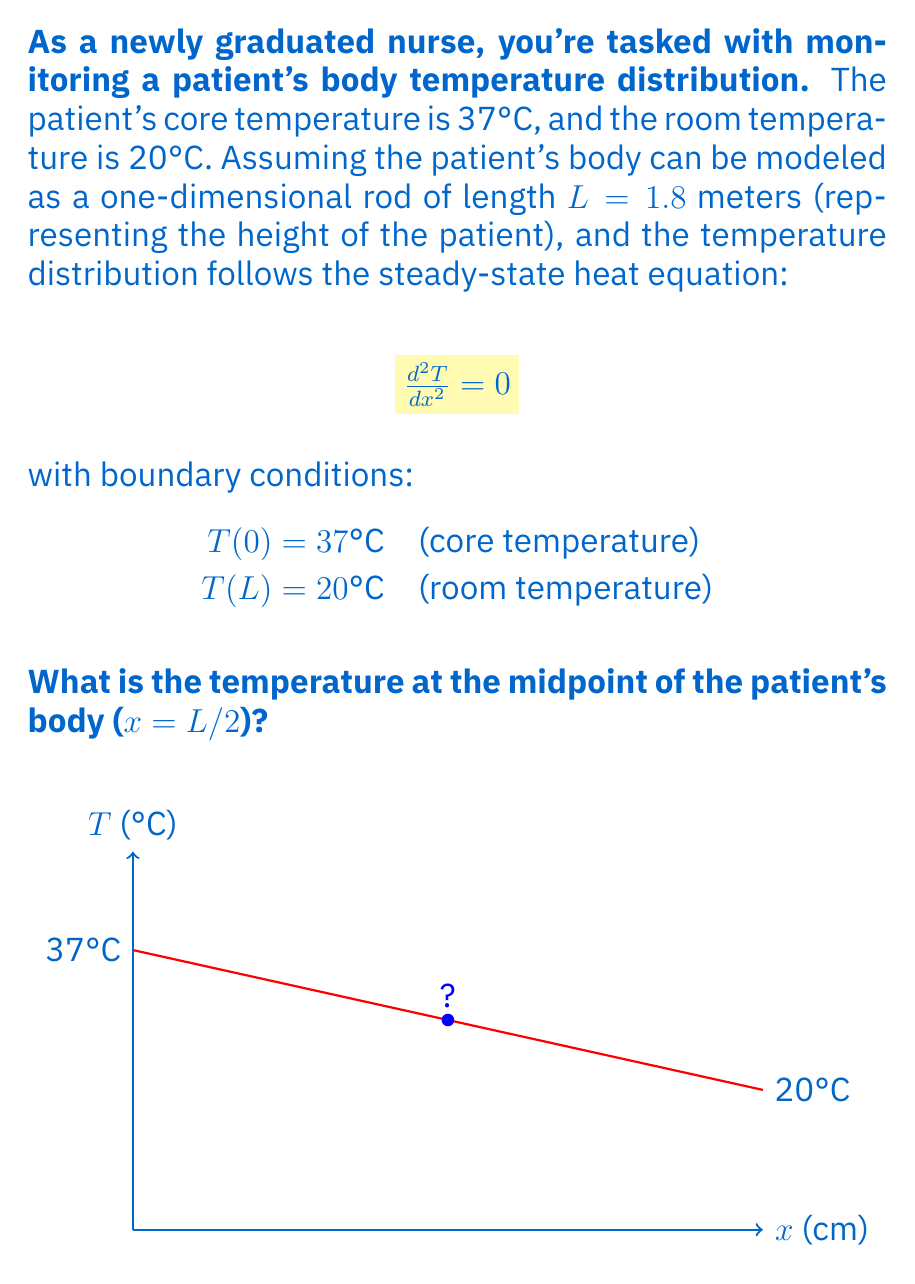Teach me how to tackle this problem. Let's solve this problem step-by-step:

1) The general solution to the steady-state heat equation $\frac{d^2T}{dx^2} = 0$ is a linear function:

   $T(x) = ax + b$, where a and b are constants.

2) We can use the boundary conditions to determine a and b:
   
   At x = 0: $T(0) = b = 37°C$
   At x = L: $T(L) = aL + b = 20°C$

3) Substituting the known values:

   $20 = a(1.8) + 37$

4) Solving for a:

   $a = \frac{20 - 37}{1.8} = -9.444°C/m$

5) Now we have the complete temperature distribution function:

   $T(x) = -9.444x + 37$

6) To find the temperature at the midpoint (x = L/2 = 0.9m), we substitute this value into our function:

   $T(0.9) = -9.444(0.9) + 37 = 28.5°C$

Therefore, the temperature at the midpoint of the patient's body is 28.5°C.
Answer: 28.5°C 